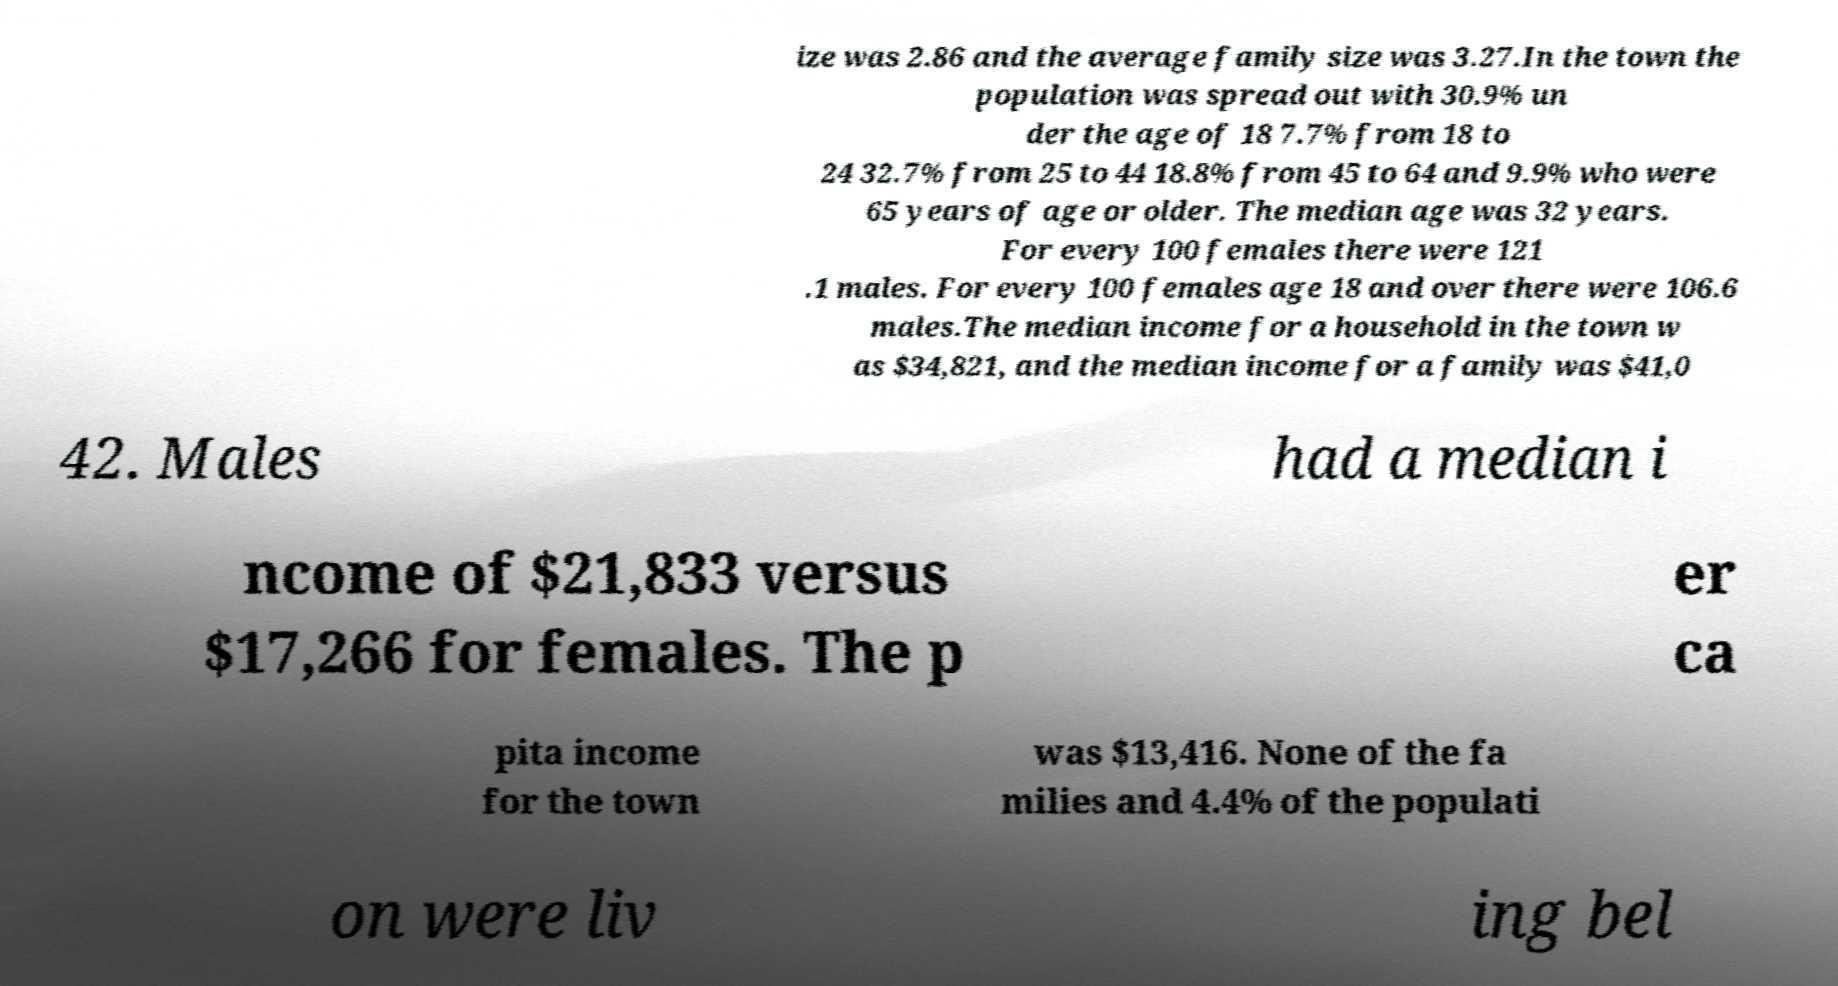There's text embedded in this image that I need extracted. Can you transcribe it verbatim? ize was 2.86 and the average family size was 3.27.In the town the population was spread out with 30.9% un der the age of 18 7.7% from 18 to 24 32.7% from 25 to 44 18.8% from 45 to 64 and 9.9% who were 65 years of age or older. The median age was 32 years. For every 100 females there were 121 .1 males. For every 100 females age 18 and over there were 106.6 males.The median income for a household in the town w as $34,821, and the median income for a family was $41,0 42. Males had a median i ncome of $21,833 versus $17,266 for females. The p er ca pita income for the town was $13,416. None of the fa milies and 4.4% of the populati on were liv ing bel 